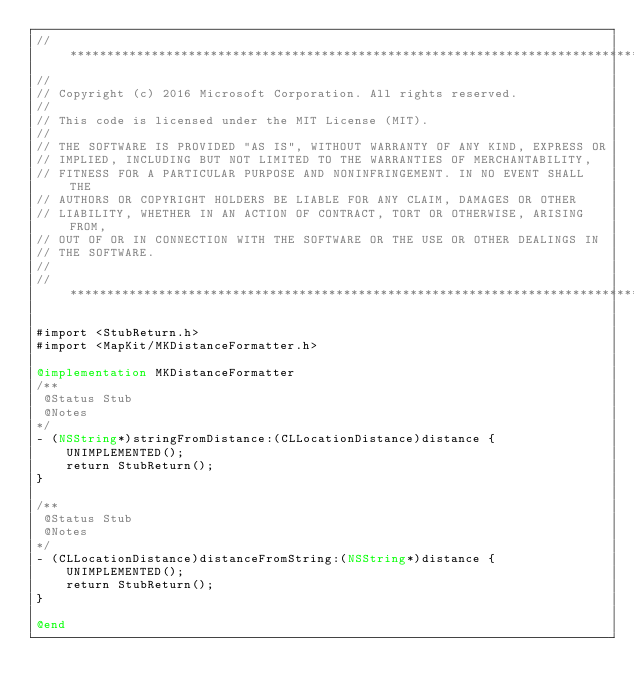Convert code to text. <code><loc_0><loc_0><loc_500><loc_500><_ObjectiveC_>//******************************************************************************
//
// Copyright (c) 2016 Microsoft Corporation. All rights reserved.
//
// This code is licensed under the MIT License (MIT).
//
// THE SOFTWARE IS PROVIDED "AS IS", WITHOUT WARRANTY OF ANY KIND, EXPRESS OR
// IMPLIED, INCLUDING BUT NOT LIMITED TO THE WARRANTIES OF MERCHANTABILITY,
// FITNESS FOR A PARTICULAR PURPOSE AND NONINFRINGEMENT. IN NO EVENT SHALL THE
// AUTHORS OR COPYRIGHT HOLDERS BE LIABLE FOR ANY CLAIM, DAMAGES OR OTHER
// LIABILITY, WHETHER IN AN ACTION OF CONTRACT, TORT OR OTHERWISE, ARISING FROM,
// OUT OF OR IN CONNECTION WITH THE SOFTWARE OR THE USE OR OTHER DEALINGS IN
// THE SOFTWARE.
//
//******************************************************************************

#import <StubReturn.h>
#import <MapKit/MKDistanceFormatter.h>

@implementation MKDistanceFormatter
/**
 @Status Stub
 @Notes
*/
- (NSString*)stringFromDistance:(CLLocationDistance)distance {
    UNIMPLEMENTED();
    return StubReturn();
}

/**
 @Status Stub
 @Notes
*/
- (CLLocationDistance)distanceFromString:(NSString*)distance {
    UNIMPLEMENTED();
    return StubReturn();
}

@end
</code> 